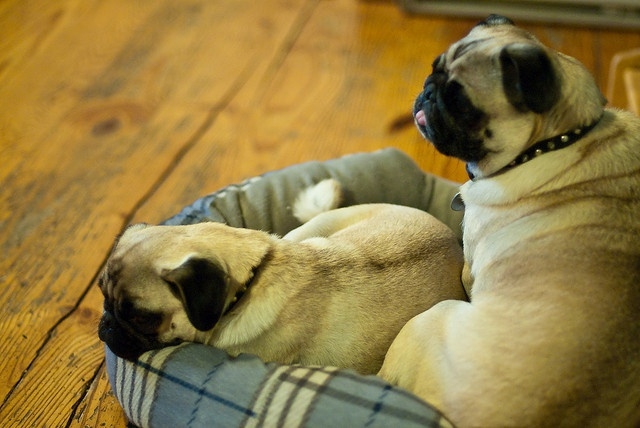Describe the objects in this image and their specific colors. I can see dog in olive, tan, black, and beige tones and dog in olive, black, and khaki tones in this image. 